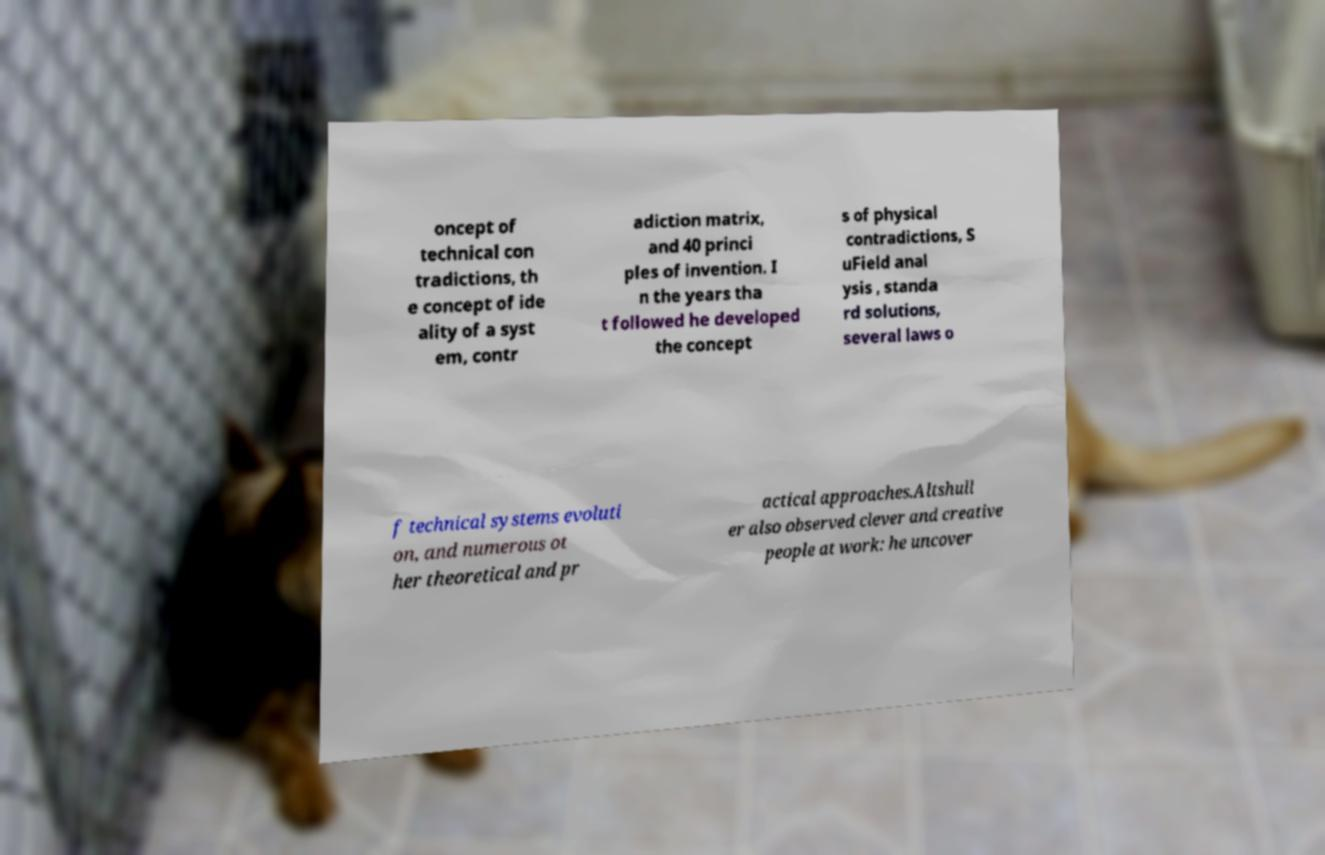Could you extract and type out the text from this image? oncept of technical con tradictions, th e concept of ide ality of a syst em, contr adiction matrix, and 40 princi ples of invention. I n the years tha t followed he developed the concept s of physical contradictions, S uField anal ysis , standa rd solutions, several laws o f technical systems evoluti on, and numerous ot her theoretical and pr actical approaches.Altshull er also observed clever and creative people at work: he uncover 